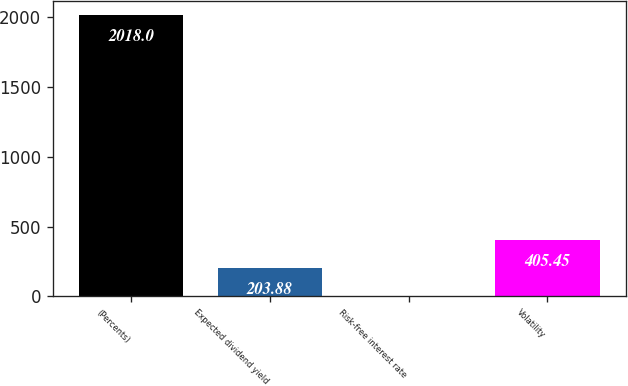<chart> <loc_0><loc_0><loc_500><loc_500><bar_chart><fcel>(Percents)<fcel>Expected dividend yield<fcel>Risk-free interest rate<fcel>Volatility<nl><fcel>2018<fcel>203.88<fcel>2.31<fcel>405.45<nl></chart> 